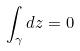<formula> <loc_0><loc_0><loc_500><loc_500>\int _ { \gamma } d z = 0</formula> 